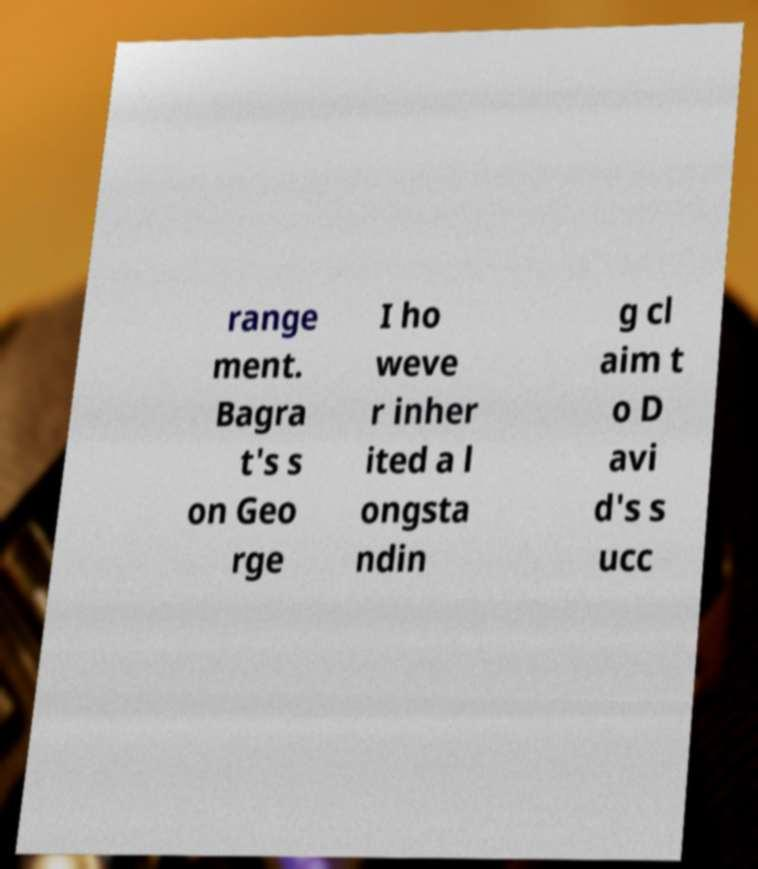What messages or text are displayed in this image? I need them in a readable, typed format. range ment. Bagra t's s on Geo rge I ho weve r inher ited a l ongsta ndin g cl aim t o D avi d's s ucc 